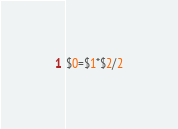Convert code to text. <code><loc_0><loc_0><loc_500><loc_500><_Awk_>$0=$1*$2/2</code> 